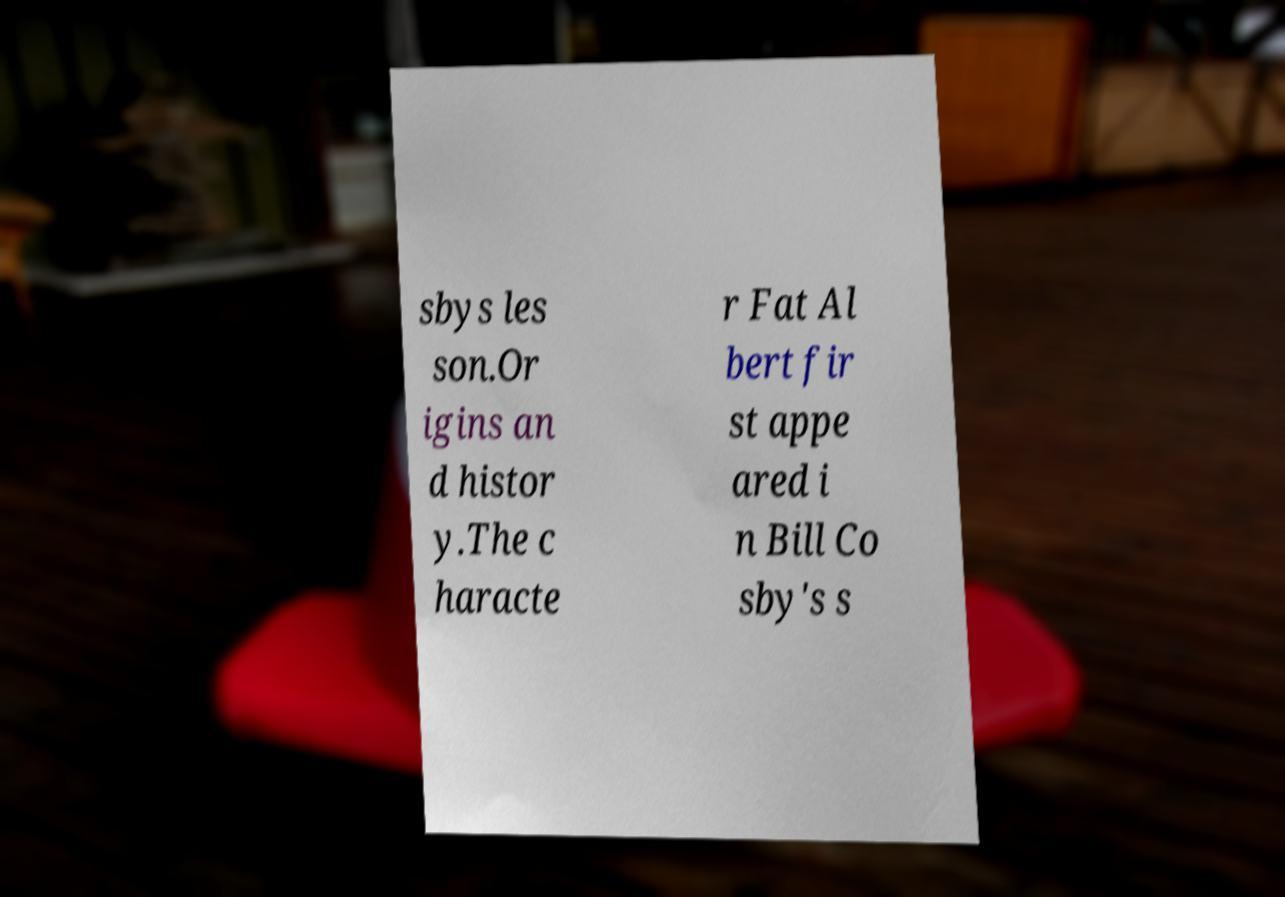Please identify and transcribe the text found in this image. sbys les son.Or igins an d histor y.The c haracte r Fat Al bert fir st appe ared i n Bill Co sby's s 